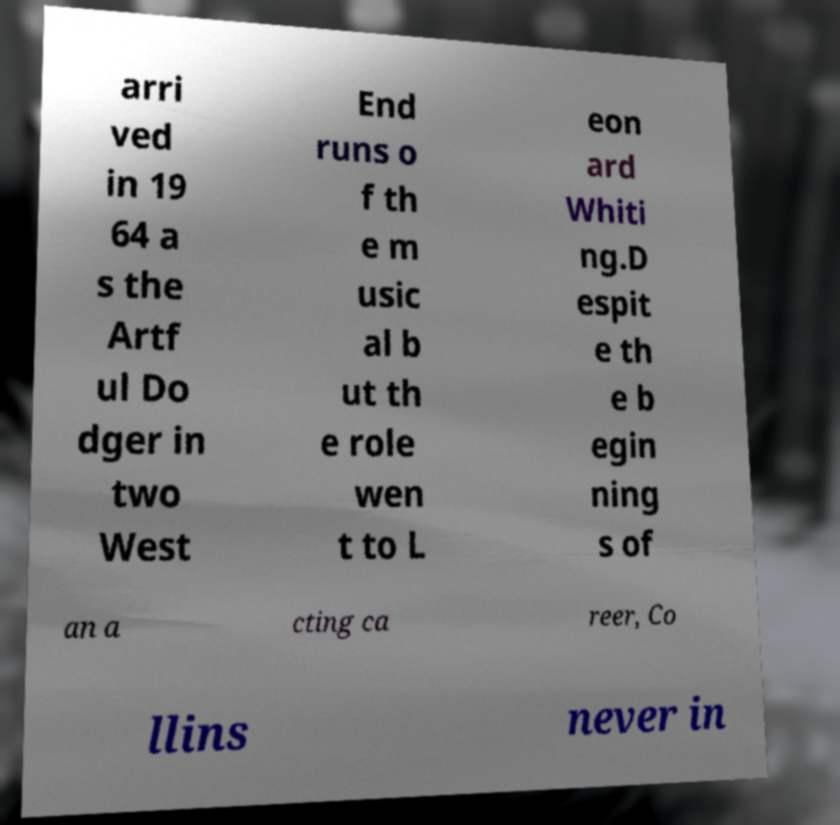Could you assist in decoding the text presented in this image and type it out clearly? arri ved in 19 64 a s the Artf ul Do dger in two West End runs o f th e m usic al b ut th e role wen t to L eon ard Whiti ng.D espit e th e b egin ning s of an a cting ca reer, Co llins never in 